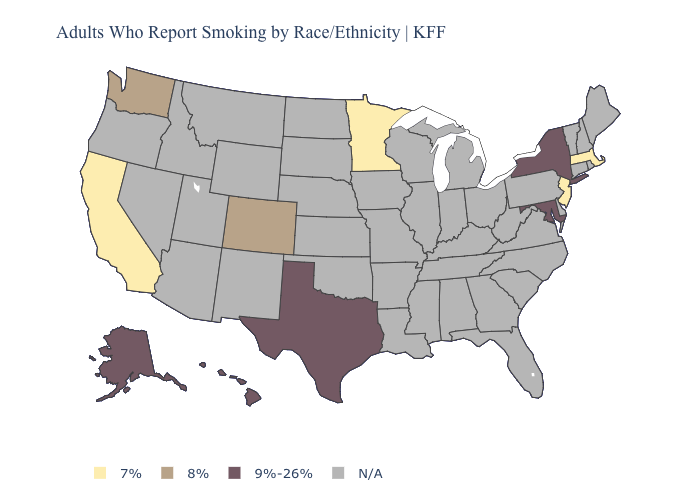What is the highest value in states that border Wisconsin?
Short answer required. 7%. Which states have the highest value in the USA?
Write a very short answer. Alaska, Hawaii, Maryland, New York, Texas. What is the value of Washington?
Write a very short answer. 8%. What is the value of Hawaii?
Concise answer only. 9%-26%. Which states have the lowest value in the USA?
Concise answer only. California, Massachusetts, Minnesota, New Jersey. What is the value of North Dakota?
Quick response, please. N/A. Name the states that have a value in the range 9%-26%?
Short answer required. Alaska, Hawaii, Maryland, New York, Texas. Name the states that have a value in the range N/A?
Keep it brief. Alabama, Arizona, Arkansas, Connecticut, Delaware, Florida, Georgia, Idaho, Illinois, Indiana, Iowa, Kansas, Kentucky, Louisiana, Maine, Michigan, Mississippi, Missouri, Montana, Nebraska, Nevada, New Hampshire, New Mexico, North Carolina, North Dakota, Ohio, Oklahoma, Oregon, Pennsylvania, Rhode Island, South Carolina, South Dakota, Tennessee, Utah, Vermont, Virginia, West Virginia, Wisconsin, Wyoming. What is the lowest value in the MidWest?
Answer briefly. 7%. Does the first symbol in the legend represent the smallest category?
Keep it brief. Yes. What is the value of Alaska?
Quick response, please. 9%-26%. Which states have the lowest value in the Northeast?
Concise answer only. Massachusetts, New Jersey. Name the states that have a value in the range 8%?
Concise answer only. Colorado, Washington. Which states hav the highest value in the South?
Concise answer only. Maryland, Texas. 